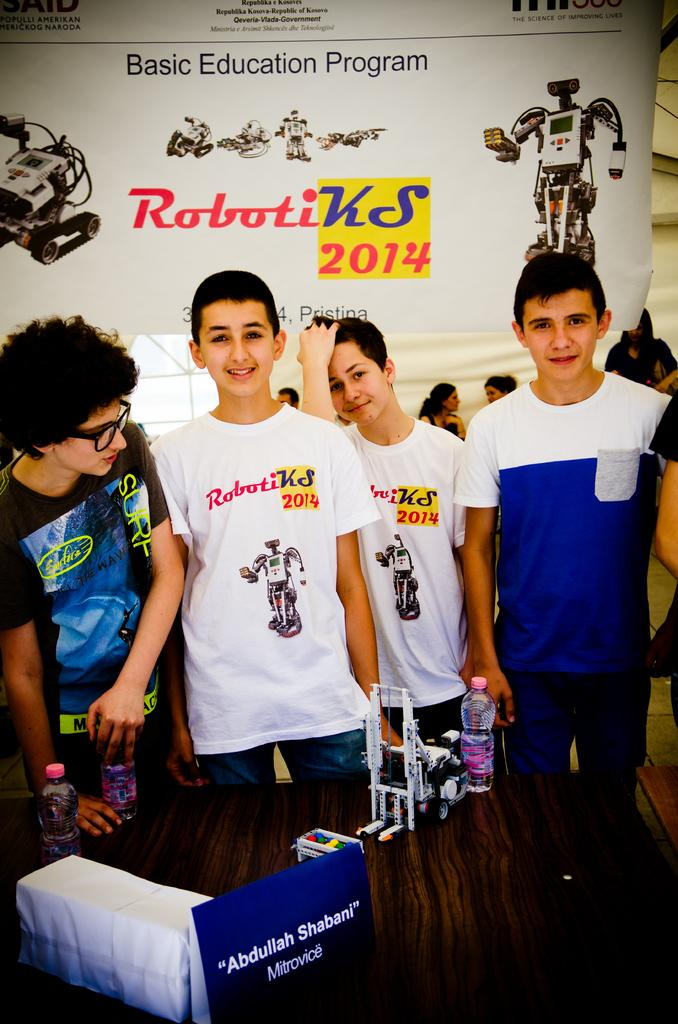<image>
Summarize the visual content of the image. Some boys standing in front of a sign that says Roboti KS 2014. 